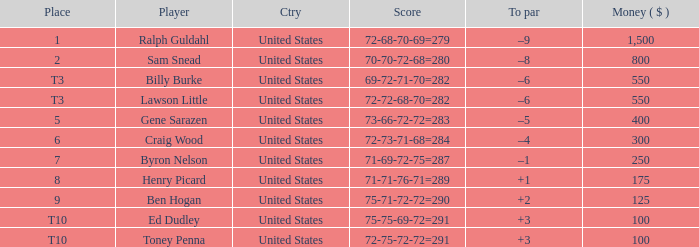Which to par has a prize less than $800? –8. 